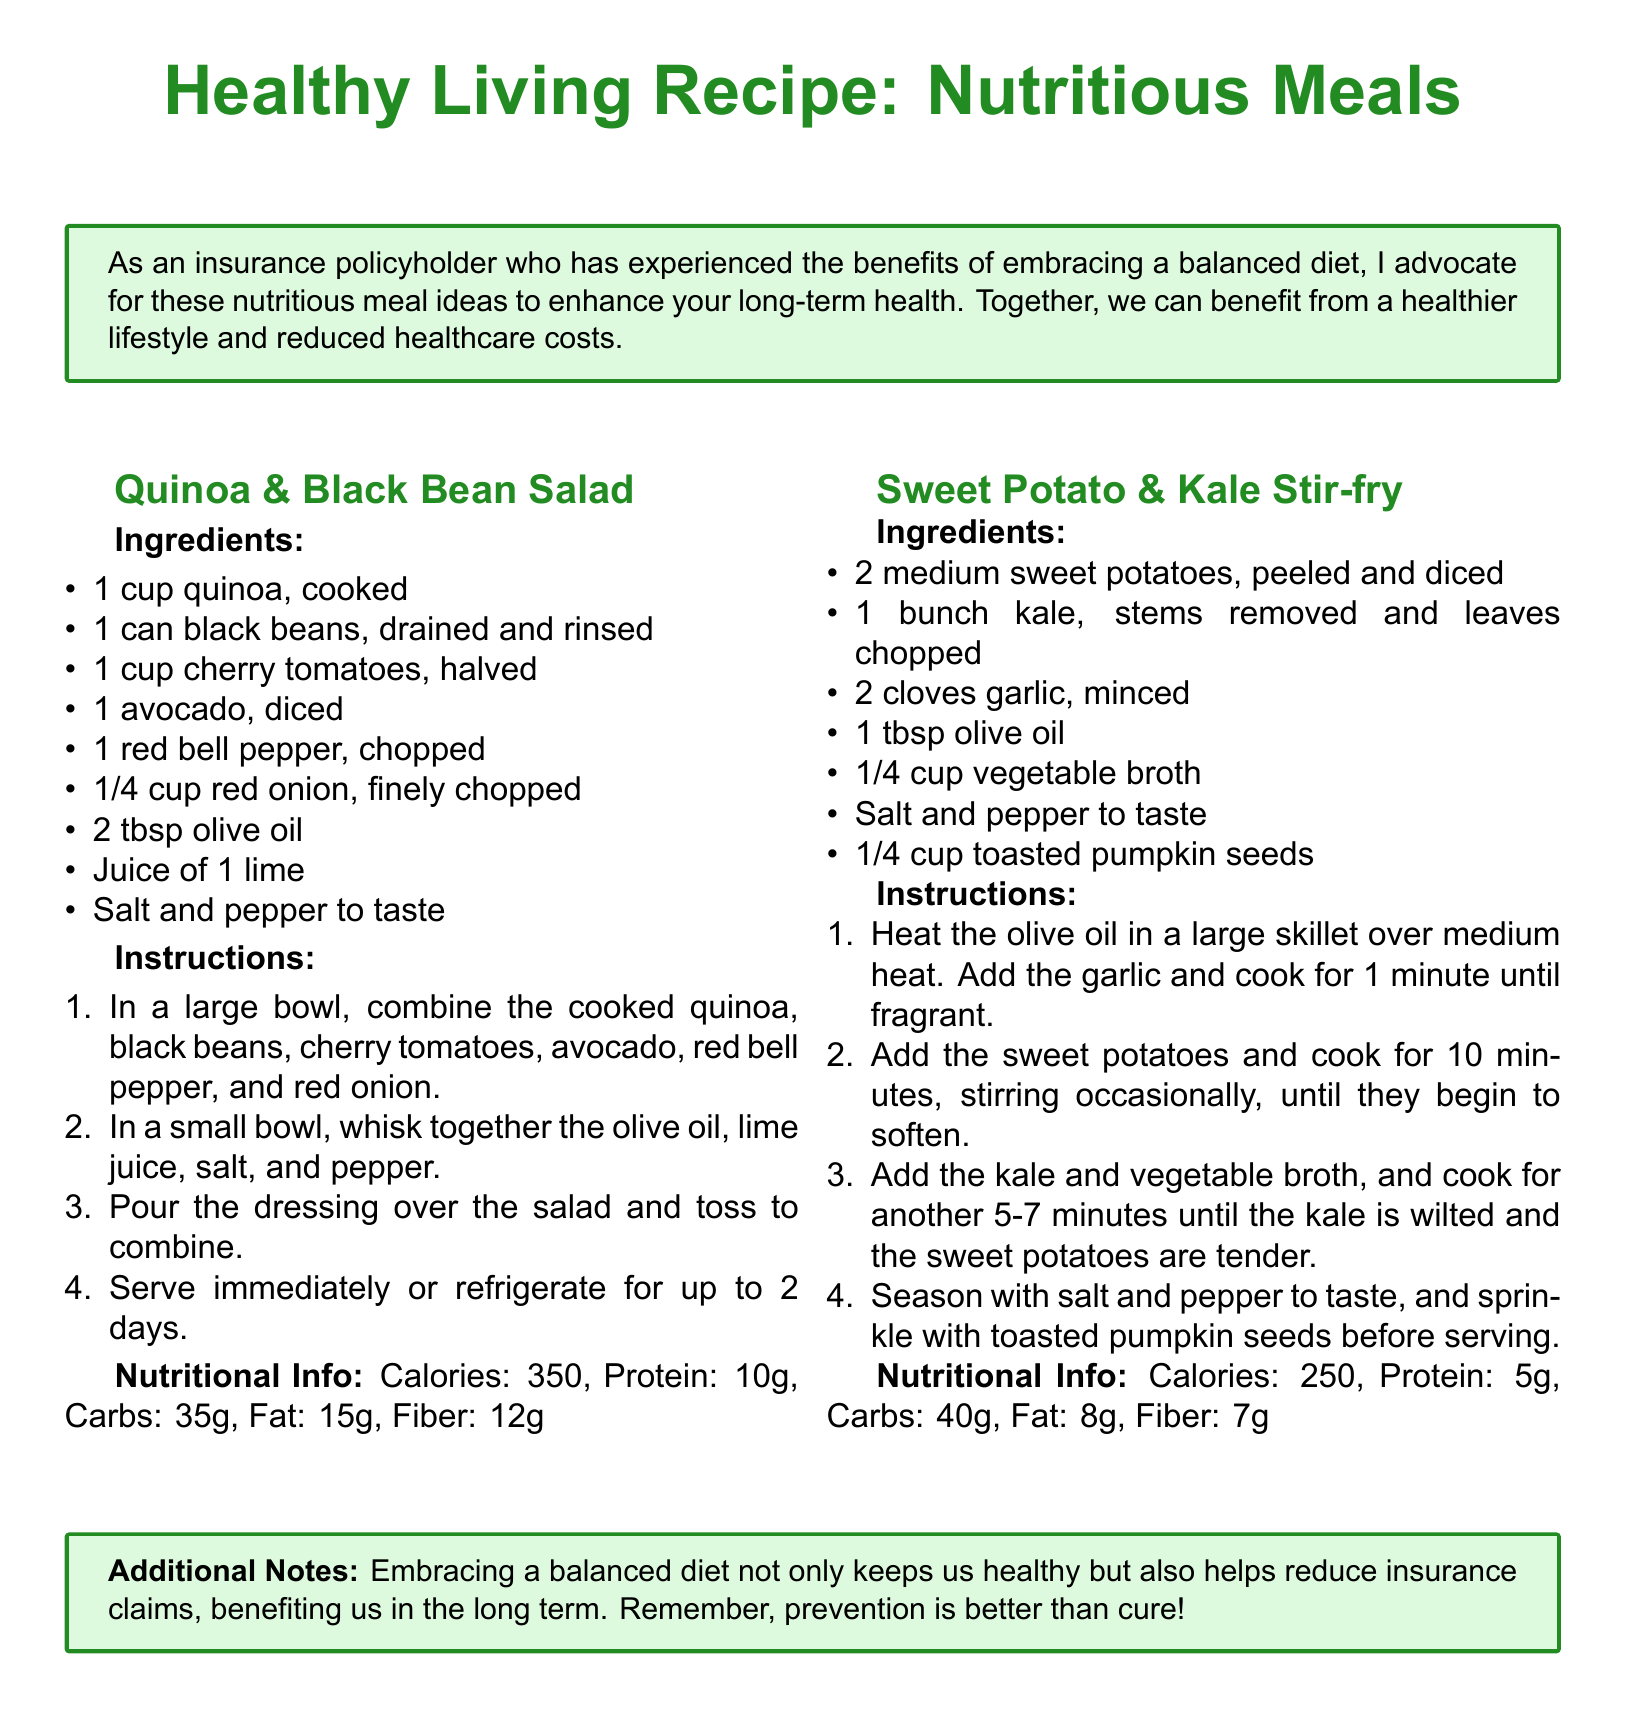What is the first recipe listed? The first recipe in the document is for Quinoa & Black Bean Salad, which is detailed in the text.
Answer: Quinoa & Black Bean Salad How many calories does the Sweet Potato & Kale Stir-fry have? The nutritional information for the Sweet Potato & Kale Stir-fry indicates it contains 250 calories.
Answer: 250 What is the main ingredient in the first recipe? The main ingredient for the Quinoa & Black Bean Salad is quinoa, as noted in the ingredients list.
Answer: Quinoa What is the total protein content in the Quinoa & Black Bean Salad? The nutritional info specifies that the Quinoa & Black Bean Salad has 10 grams of protein.
Answer: 10g How many ingredients are required for the Sweet Potato & Kale Stir-fry? The list of ingredients for the Sweet Potato & Kale Stir-fry contains 7 items, as detailed in the document.
Answer: 7 Which nutrient content is higher in the Sweet Potato & Kale Stir-fry compared to the Quinoa & Black Bean Salad? The Sweet Potato & Kale Stir-fry has higher carbohydrate content with 40 grams, while the Quinoa & Black Bean Salad has 35 grams.
Answer: Carbohydrates What is advised for long-term benefits regarding diet? The document advocates that embracing a balanced diet helps reduce insurance claims, which reflects long-term health benefits.
Answer: Balanced diet 